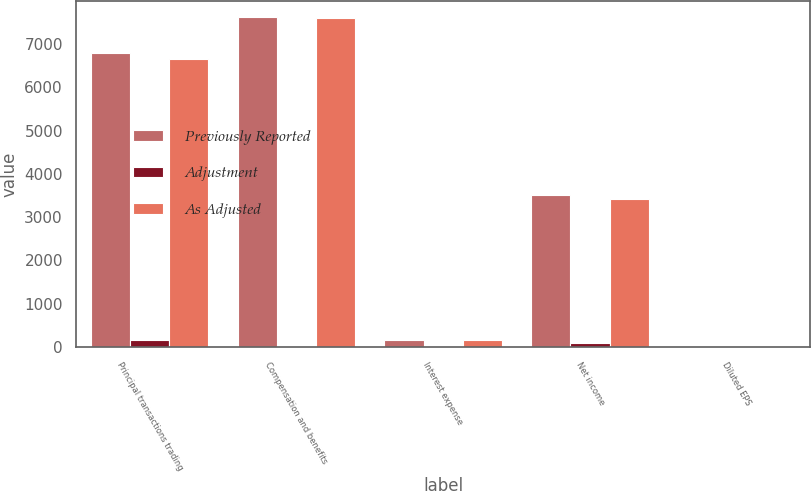Convert chart. <chart><loc_0><loc_0><loc_500><loc_500><stacked_bar_chart><ecel><fcel>Principal transactions trading<fcel>Compensation and benefits<fcel>Interest expense<fcel>Net income<fcel>Diluted EPS<nl><fcel>Previously Reported<fcel>6802<fcel>7619<fcel>157<fcel>3518<fcel>3.33<nl><fcel>Adjustment<fcel>157<fcel>22<fcel>24<fcel>103<fcel>0.1<nl><fcel>As Adjusted<fcel>6645<fcel>7597<fcel>157<fcel>3415<fcel>3.23<nl></chart> 